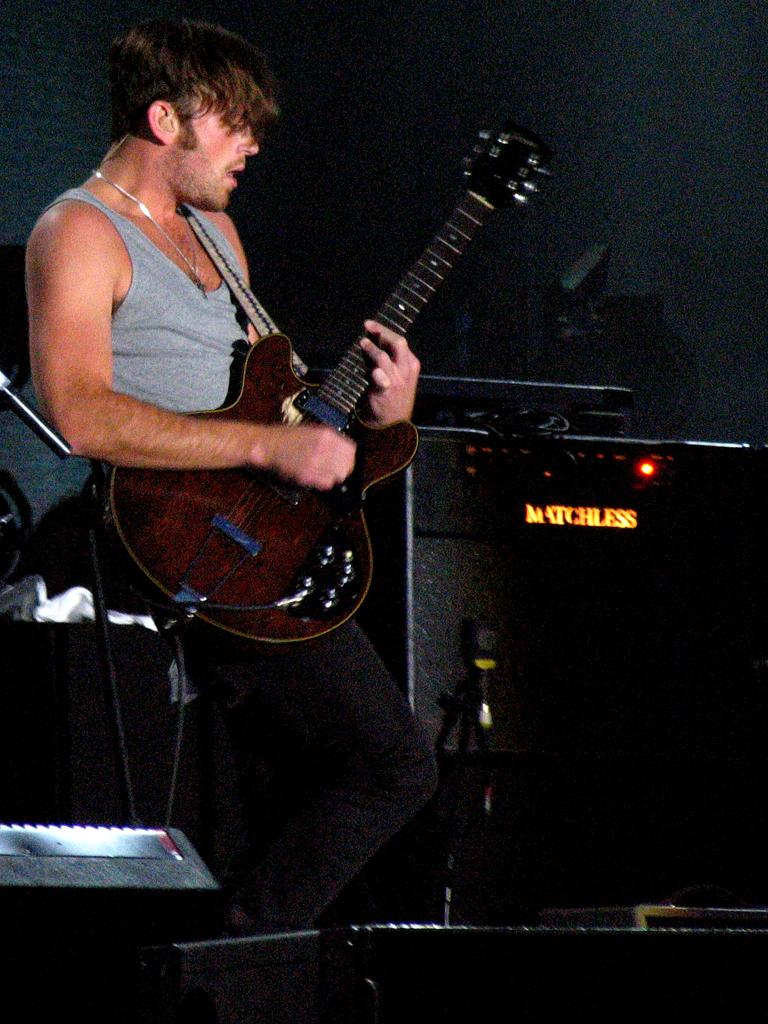What is the man in the picture doing? The man is holding a guitar and singing. What object is the man holding in the image? The man is holding a guitar. What can be seen in the background of the image? There is a wall in the background of the image. Reasoning: Let's think step by step by step in order to produce the conversation. We start by identifying the main subject in the image, which is the man. Then, we describe what the man is doing, which is holding a guitar and singing. We also mention the presence of a wall in the background. Each question is designed to elicit a specific detail about the image that is known from the provided facts. Absurd Question/Answer: How many spades are visible in the image? There are no spades present in the image. What type of hands is the man using to play the guitar in the image? The image does not show the man's hands, so it cannot be determined what type of hands he is using to play the guitar. Can you see the man's ear in the image? The image does not show the man's ear, so it cannot be determined if it is visible. 